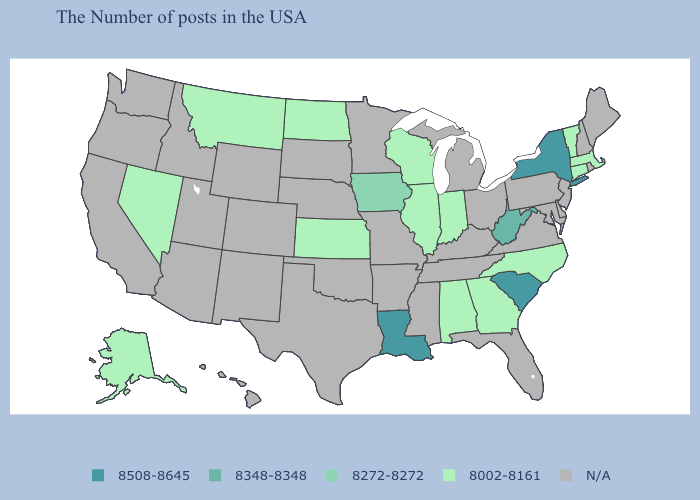Which states have the highest value in the USA?
Concise answer only. New York, South Carolina, Louisiana. Name the states that have a value in the range N/A?
Answer briefly. Maine, Rhode Island, New Hampshire, New Jersey, Delaware, Maryland, Pennsylvania, Virginia, Ohio, Florida, Michigan, Kentucky, Tennessee, Mississippi, Missouri, Arkansas, Minnesota, Nebraska, Oklahoma, Texas, South Dakota, Wyoming, Colorado, New Mexico, Utah, Arizona, Idaho, California, Washington, Oregon, Hawaii. Name the states that have a value in the range 8272-8272?
Short answer required. Iowa. Name the states that have a value in the range 8508-8645?
Quick response, please. New York, South Carolina, Louisiana. Name the states that have a value in the range 8348-8348?
Quick response, please. West Virginia. Name the states that have a value in the range 8002-8161?
Short answer required. Massachusetts, Vermont, Connecticut, North Carolina, Georgia, Indiana, Alabama, Wisconsin, Illinois, Kansas, North Dakota, Montana, Nevada, Alaska. Name the states that have a value in the range N/A?
Give a very brief answer. Maine, Rhode Island, New Hampshire, New Jersey, Delaware, Maryland, Pennsylvania, Virginia, Ohio, Florida, Michigan, Kentucky, Tennessee, Mississippi, Missouri, Arkansas, Minnesota, Nebraska, Oklahoma, Texas, South Dakota, Wyoming, Colorado, New Mexico, Utah, Arizona, Idaho, California, Washington, Oregon, Hawaii. Name the states that have a value in the range 8002-8161?
Concise answer only. Massachusetts, Vermont, Connecticut, North Carolina, Georgia, Indiana, Alabama, Wisconsin, Illinois, Kansas, North Dakota, Montana, Nevada, Alaska. What is the value of Rhode Island?
Short answer required. N/A. Which states have the lowest value in the MidWest?
Quick response, please. Indiana, Wisconsin, Illinois, Kansas, North Dakota. What is the lowest value in the USA?
Answer briefly. 8002-8161. What is the lowest value in the USA?
Keep it brief. 8002-8161. Does the first symbol in the legend represent the smallest category?
Short answer required. No. Does Massachusetts have the lowest value in the USA?
Keep it brief. Yes. 